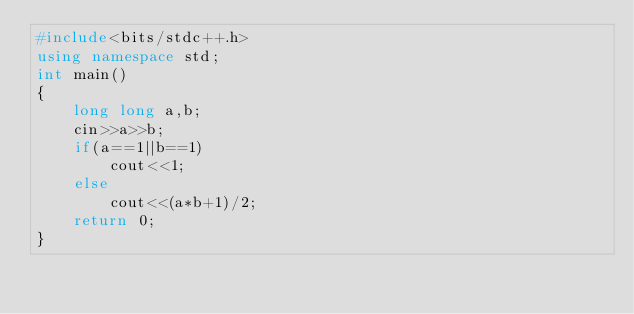Convert code to text. <code><loc_0><loc_0><loc_500><loc_500><_C++_>#include<bits/stdc++.h>
using namespace std;
int main()
{
	long long a,b;
	cin>>a>>b;
	if(a==1||b==1)
		cout<<1;
	else
		cout<<(a*b+1)/2;
	return 0;
}</code> 